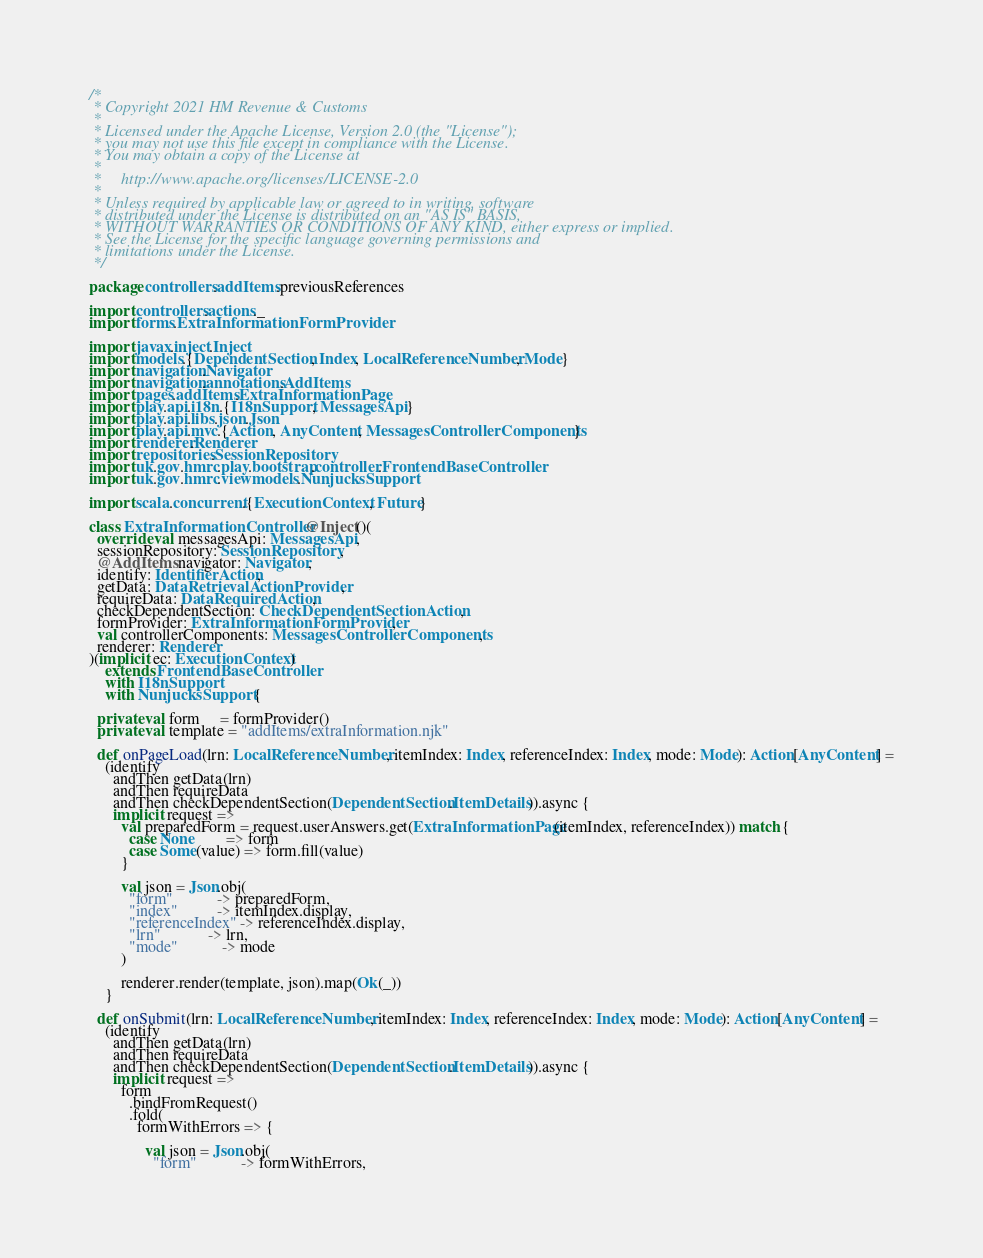<code> <loc_0><loc_0><loc_500><loc_500><_Scala_>/*
 * Copyright 2021 HM Revenue & Customs
 *
 * Licensed under the Apache License, Version 2.0 (the "License");
 * you may not use this file except in compliance with the License.
 * You may obtain a copy of the License at
 *
 *     http://www.apache.org/licenses/LICENSE-2.0
 *
 * Unless required by applicable law or agreed to in writing, software
 * distributed under the License is distributed on an "AS IS" BASIS,
 * WITHOUT WARRANTIES OR CONDITIONS OF ANY KIND, either express or implied.
 * See the License for the specific language governing permissions and
 * limitations under the License.
 */

package controllers.addItems.previousReferences

import controllers.actions._
import forms.ExtraInformationFormProvider

import javax.inject.Inject
import models.{DependentSection, Index, LocalReferenceNumber, Mode}
import navigation.Navigator
import navigation.annotations.AddItems
import pages.addItems.ExtraInformationPage
import play.api.i18n.{I18nSupport, MessagesApi}
import play.api.libs.json.Json
import play.api.mvc.{Action, AnyContent, MessagesControllerComponents}
import renderer.Renderer
import repositories.SessionRepository
import uk.gov.hmrc.play.bootstrap.controller.FrontendBaseController
import uk.gov.hmrc.viewmodels.NunjucksSupport

import scala.concurrent.{ExecutionContext, Future}

class ExtraInformationController @Inject()(
  override val messagesApi: MessagesApi,
  sessionRepository: SessionRepository,
  @AddItems navigator: Navigator,
  identify: IdentifierAction,
  getData: DataRetrievalActionProvider,
  requireData: DataRequiredAction,
  checkDependentSection: CheckDependentSectionAction,
  formProvider: ExtraInformationFormProvider,
  val controllerComponents: MessagesControllerComponents,
  renderer: Renderer
)(implicit ec: ExecutionContext)
    extends FrontendBaseController
    with I18nSupport
    with NunjucksSupport {

  private val form     = formProvider()
  private val template = "addItems/extraInformation.njk"

  def onPageLoad(lrn: LocalReferenceNumber, itemIndex: Index, referenceIndex: Index, mode: Mode): Action[AnyContent] =
    (identify
      andThen getData(lrn)
      andThen requireData
      andThen checkDependentSection(DependentSection.ItemDetails)).async {
      implicit request =>
        val preparedForm = request.userAnswers.get(ExtraInformationPage(itemIndex, referenceIndex)) match {
          case None        => form
          case Some(value) => form.fill(value)
        }

        val json = Json.obj(
          "form"           -> preparedForm,
          "index"          -> itemIndex.display,
          "referenceIndex" -> referenceIndex.display,
          "lrn"            -> lrn,
          "mode"           -> mode
        )

        renderer.render(template, json).map(Ok(_))
    }

  def onSubmit(lrn: LocalReferenceNumber, itemIndex: Index, referenceIndex: Index, mode: Mode): Action[AnyContent] =
    (identify
      andThen getData(lrn)
      andThen requireData
      andThen checkDependentSection(DependentSection.ItemDetails)).async {
      implicit request =>
        form
          .bindFromRequest()
          .fold(
            formWithErrors => {

              val json = Json.obj(
                "form"           -> formWithErrors,</code> 